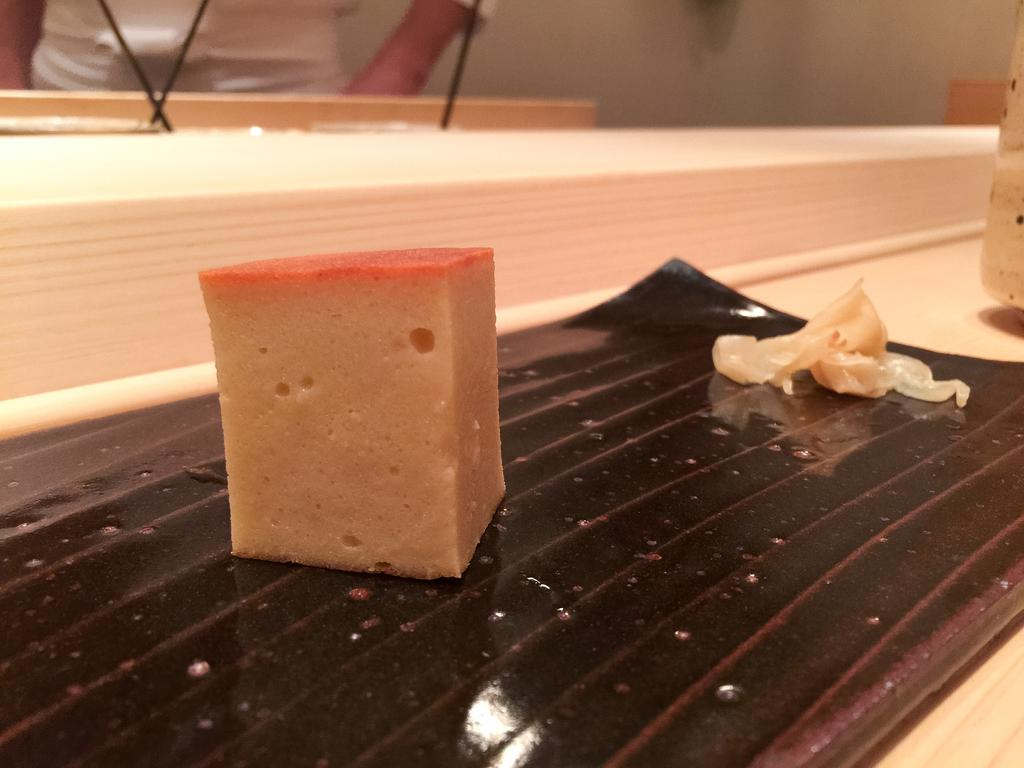What is the main subject of the image? There is a food item in the image. Can you describe the setting of the image? There is an object on a sheet, which is on a platform. What can be seen in the background of the image? There is a wall in the background of the image, and there is a person in the background, but they are truncated. What type of rifle is the person holding in the image? There is no rifle present in the image. Can you describe the type of meat being prepared in the image? There is no meat present in the image. 